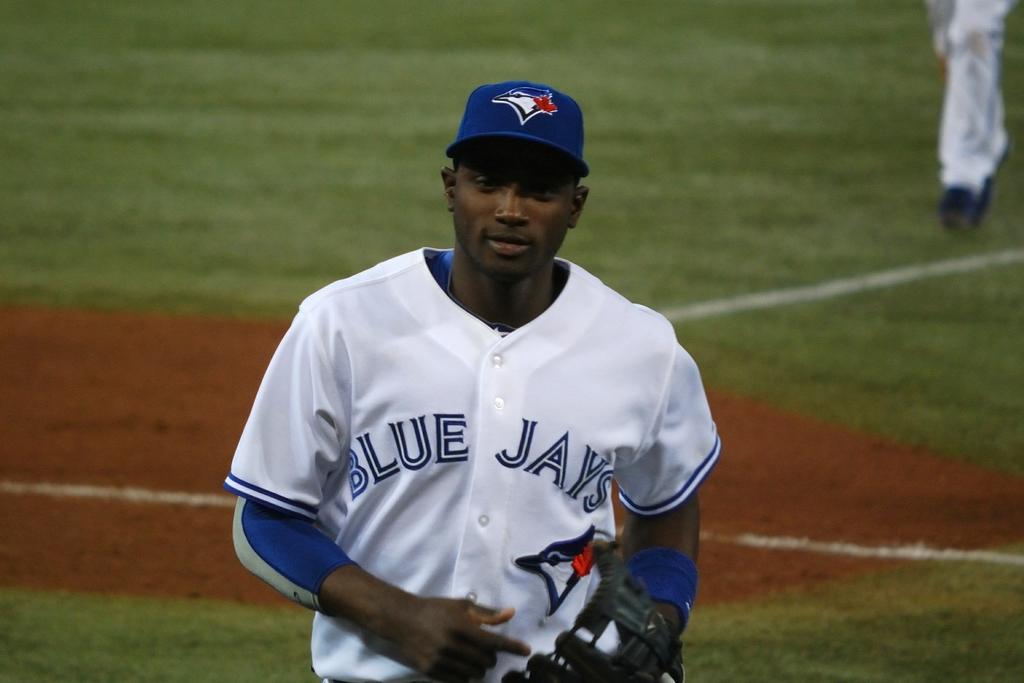What team does the man play for?
Your response must be concise. Blue jays. 